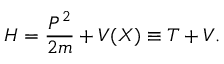Convert formula to latex. <formula><loc_0><loc_0><loc_500><loc_500>H = \frac { P ^ { 2 } } { 2 m } + V ( X ) \equiv T + V .</formula> 